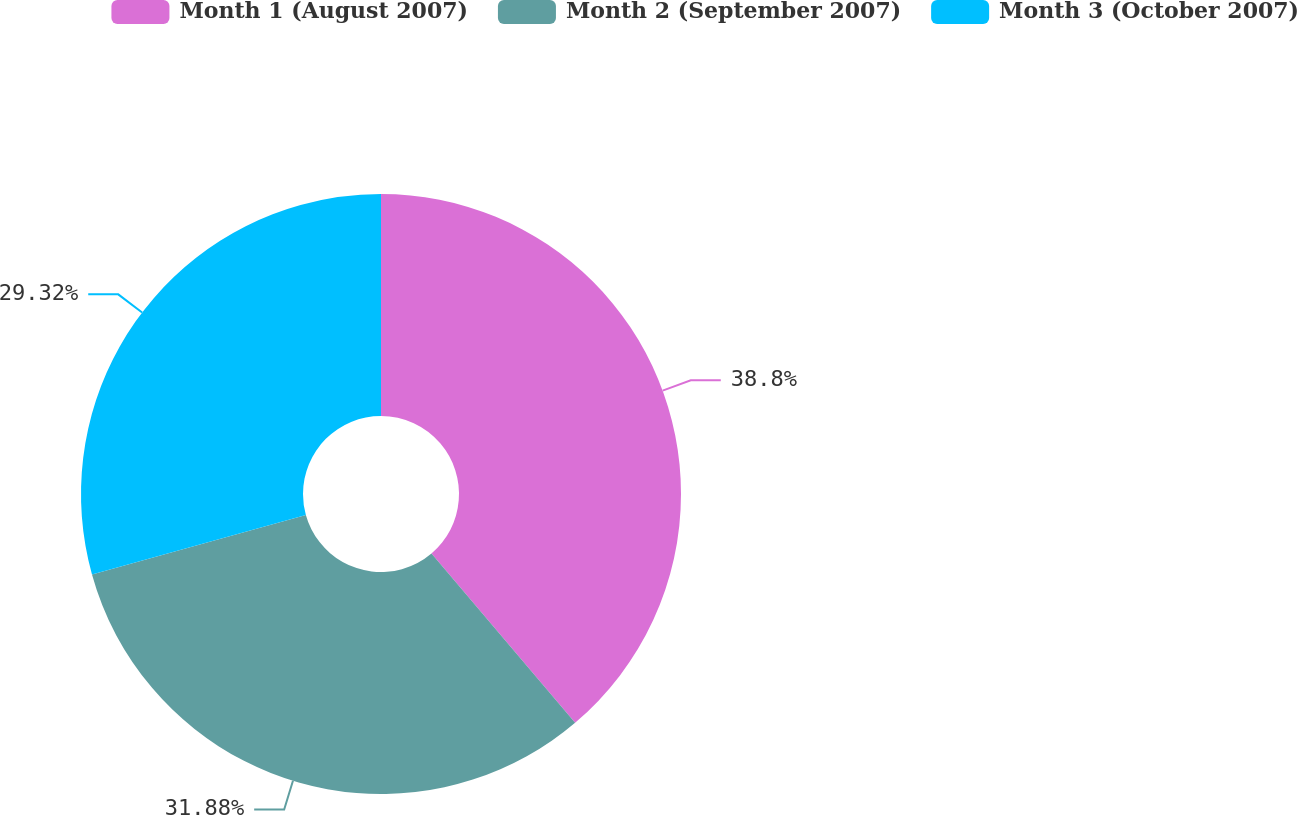Convert chart to OTSL. <chart><loc_0><loc_0><loc_500><loc_500><pie_chart><fcel>Month 1 (August 2007)<fcel>Month 2 (September 2007)<fcel>Month 3 (October 2007)<nl><fcel>38.8%<fcel>31.88%<fcel>29.32%<nl></chart> 